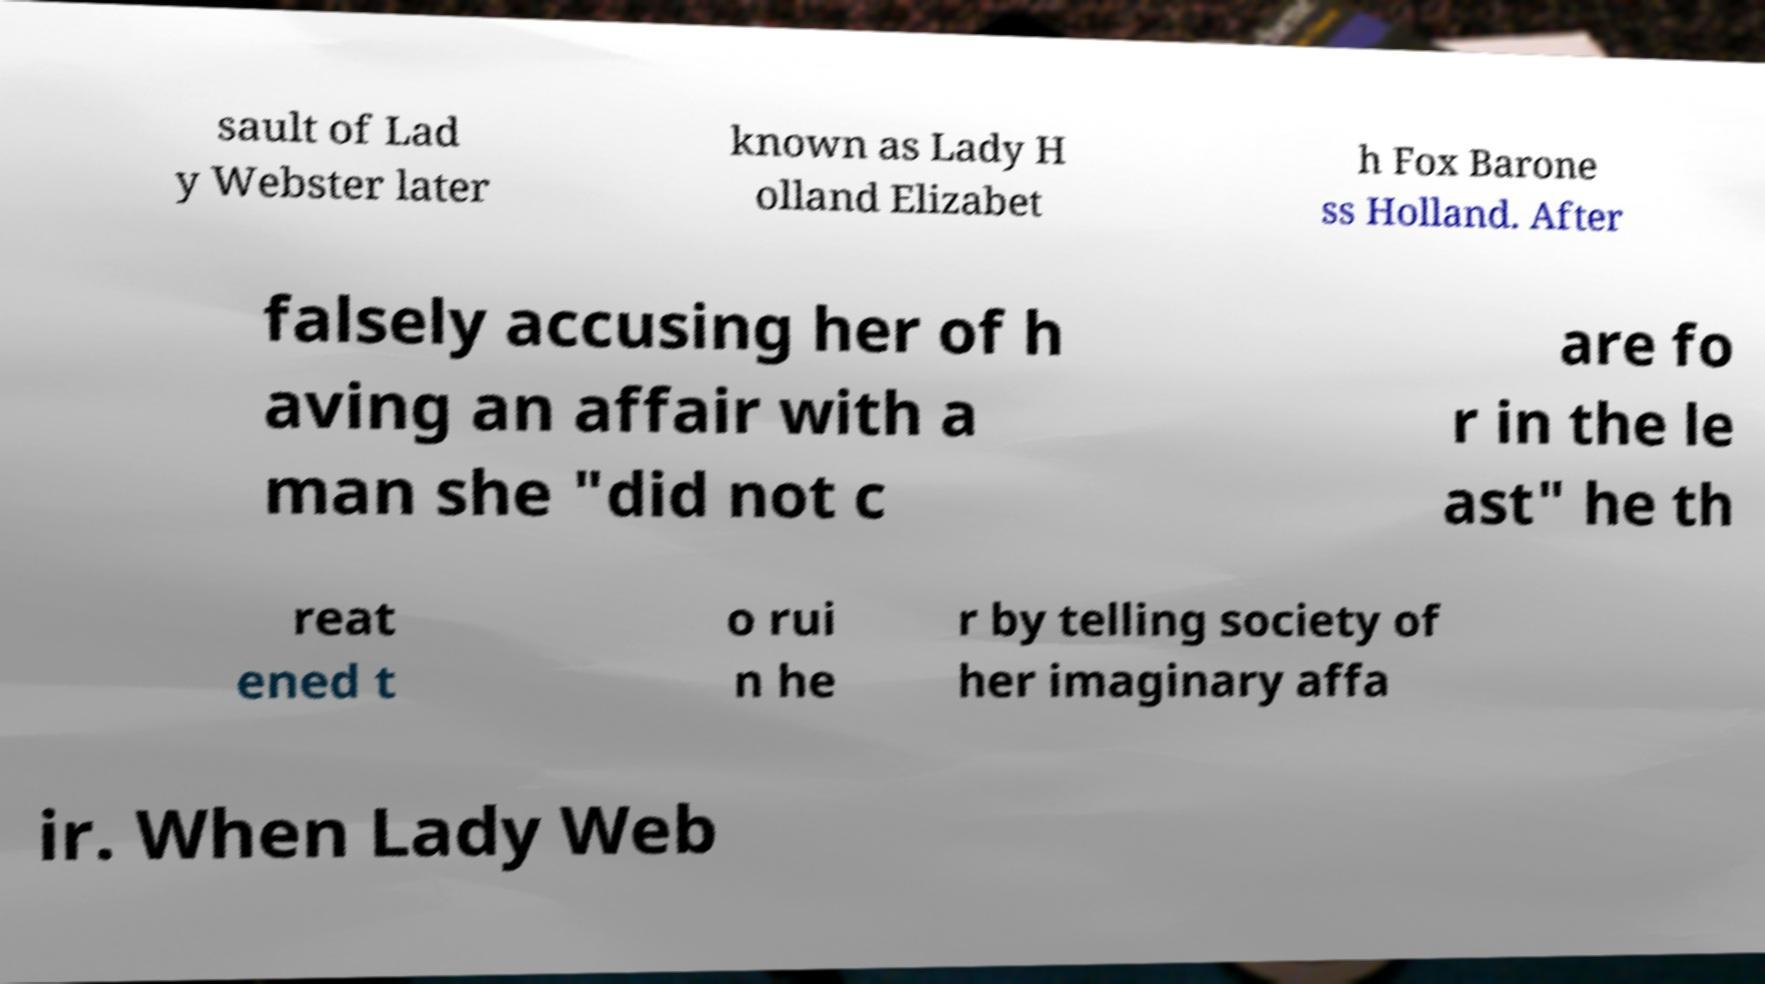What messages or text are displayed in this image? I need them in a readable, typed format. sault of Lad y Webster later known as Lady H olland Elizabet h Fox Barone ss Holland. After falsely accusing her of h aving an affair with a man she "did not c are fo r in the le ast" he th reat ened t o rui n he r by telling society of her imaginary affa ir. When Lady Web 